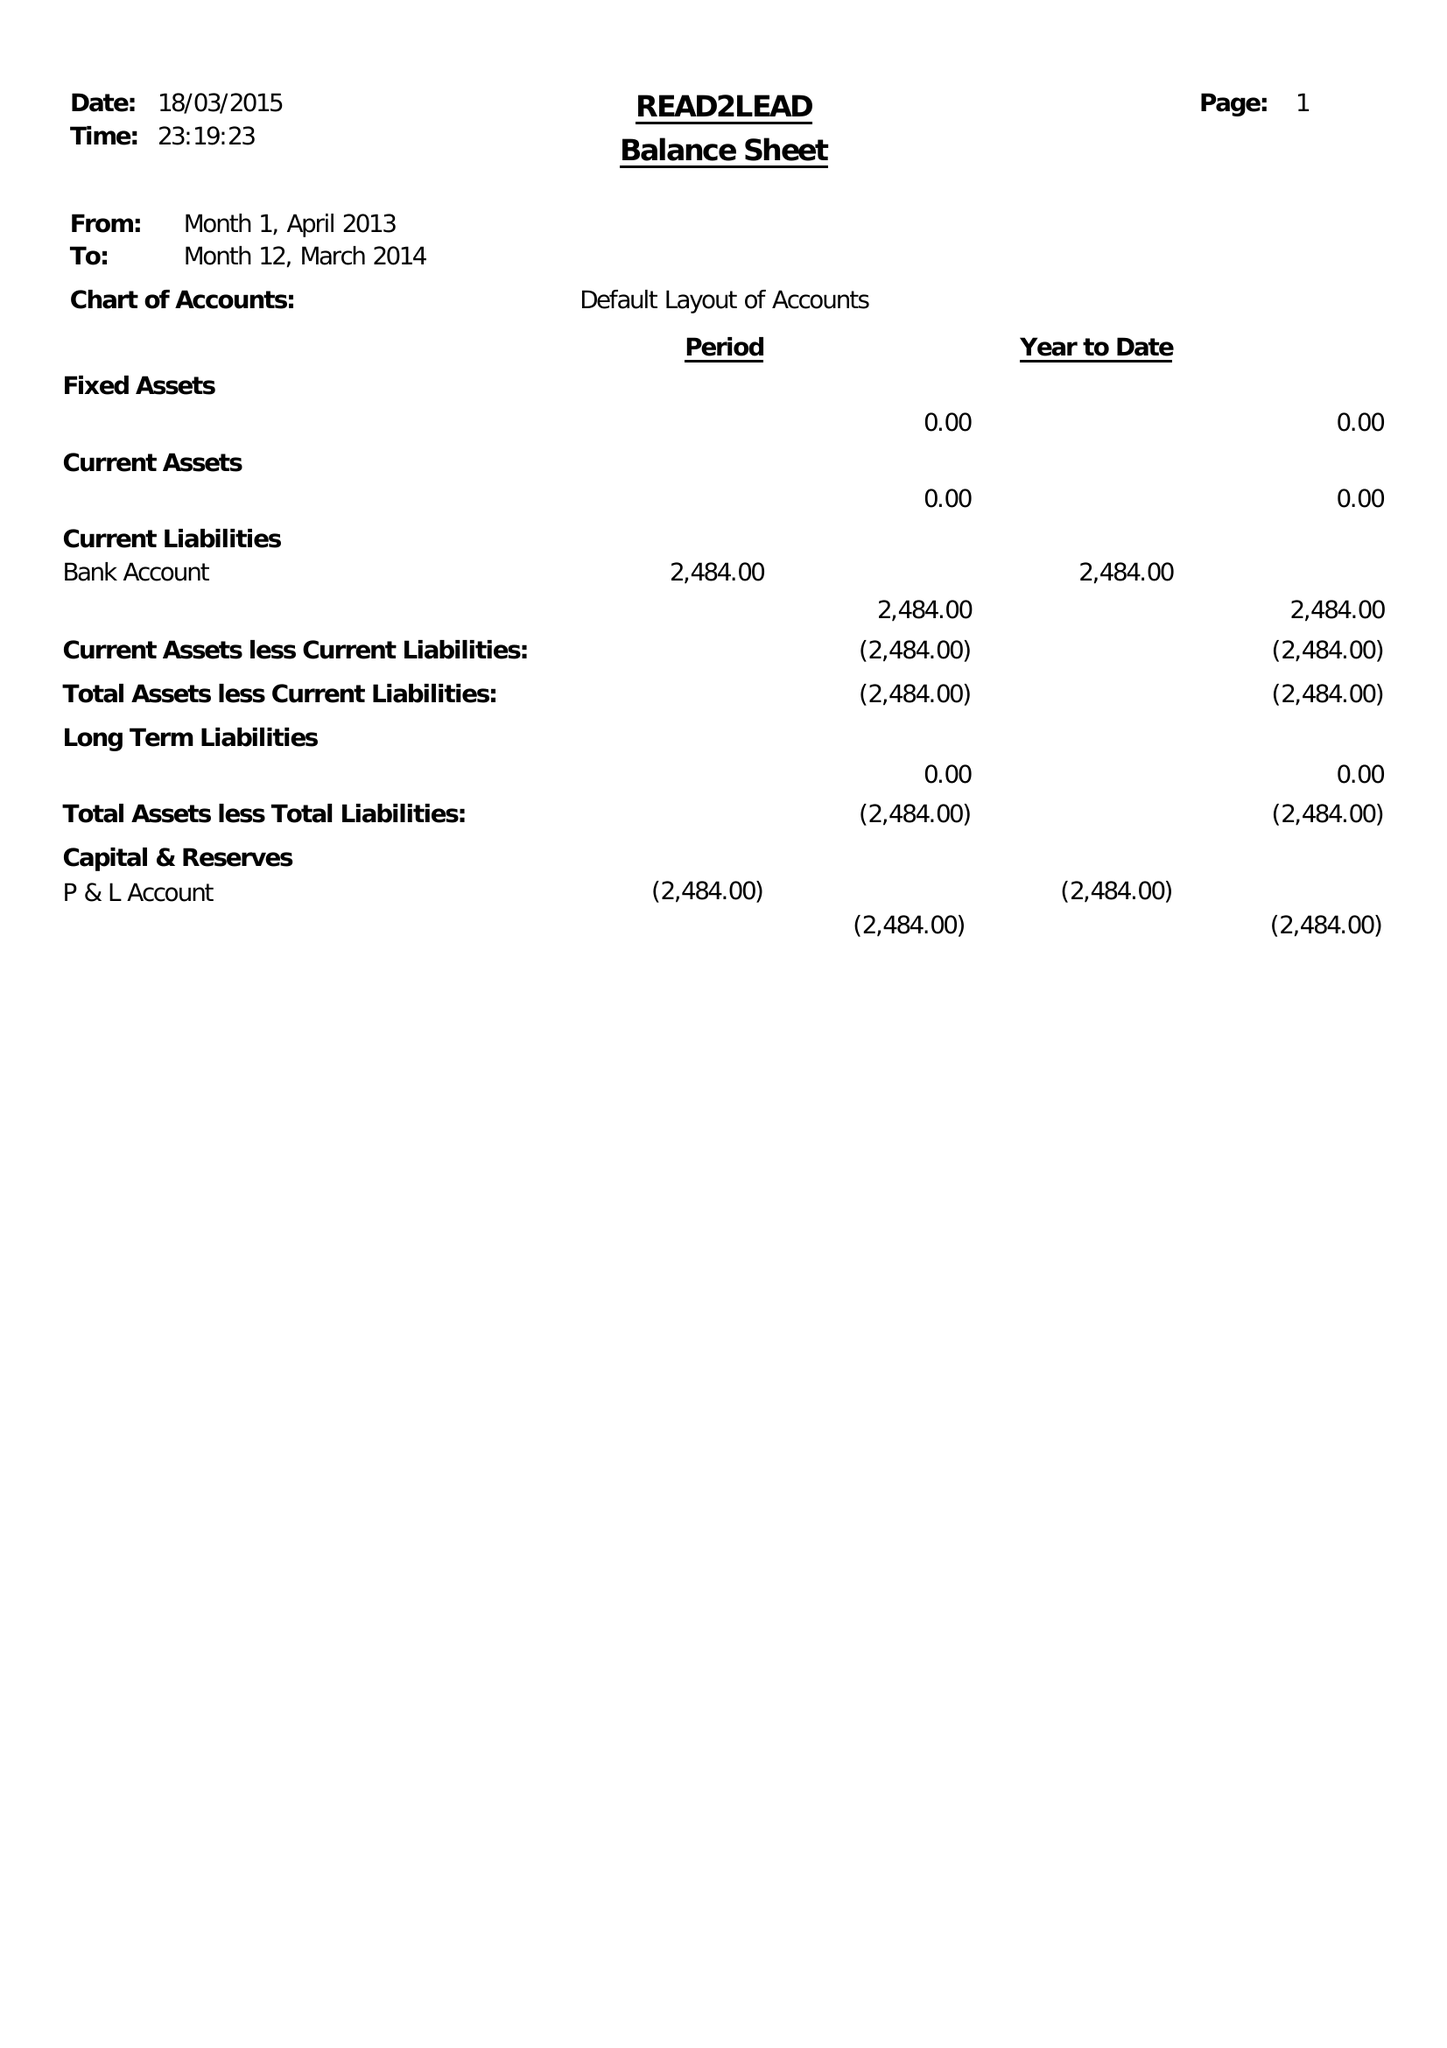What is the value for the charity_number?
Answer the question using a single word or phrase. 1151490 